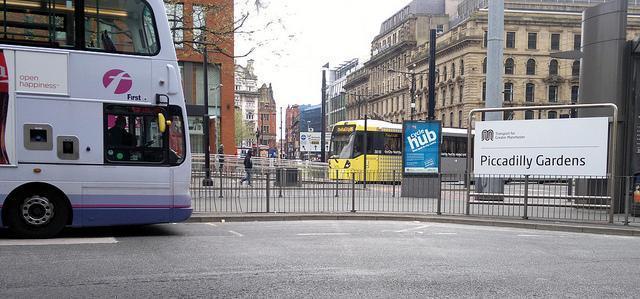How many buses are in the picture?
Give a very brief answer. 2. How many buses are there?
Give a very brief answer. 2. How many buses?
Give a very brief answer. 2. How many buses can you see?
Give a very brief answer. 2. How many oxygen tubes is the man in the bed wearing?
Give a very brief answer. 0. 